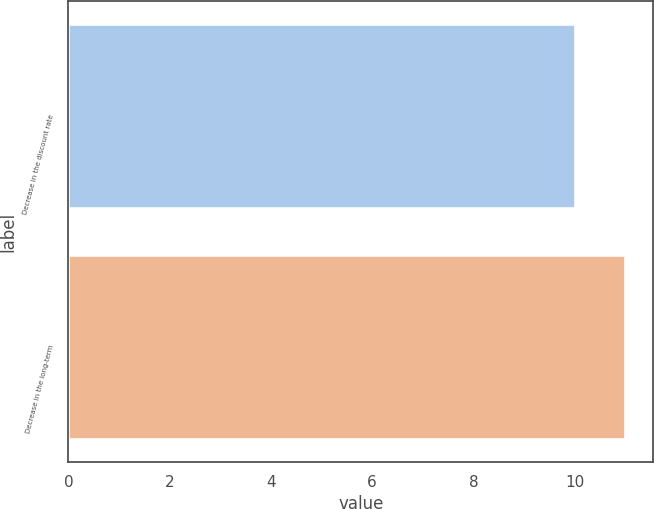<chart> <loc_0><loc_0><loc_500><loc_500><bar_chart><fcel>Decrease in the discount rate<fcel>Decrease in the long-term<nl><fcel>10<fcel>11<nl></chart> 